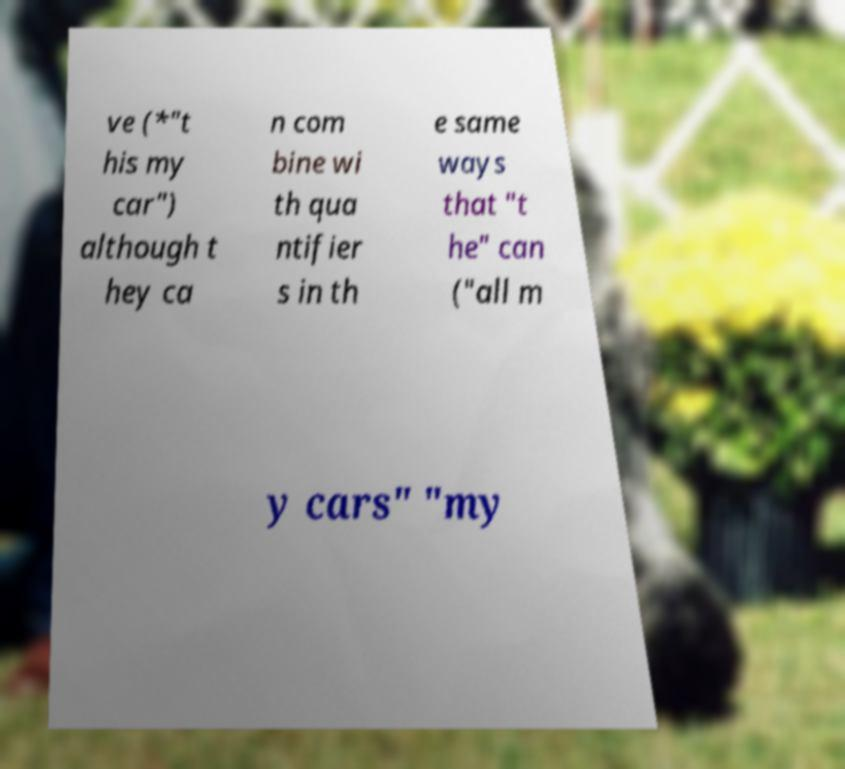What messages or text are displayed in this image? I need them in a readable, typed format. ve (*"t his my car") although t hey ca n com bine wi th qua ntifier s in th e same ways that "t he" can ("all m y cars" "my 